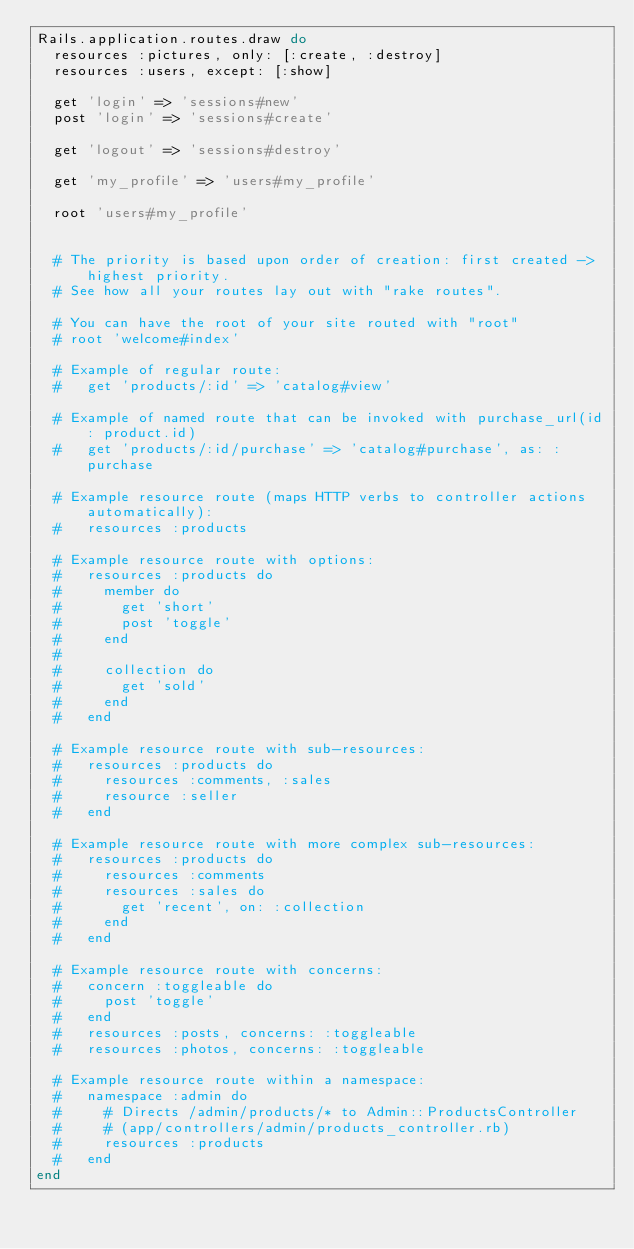<code> <loc_0><loc_0><loc_500><loc_500><_Ruby_>Rails.application.routes.draw do
  resources :pictures, only: [:create, :destroy]
  resources :users, except: [:show]

  get 'login' => 'sessions#new'
  post 'login' => 'sessions#create'

  get 'logout' => 'sessions#destroy'

  get 'my_profile' => 'users#my_profile'

  root 'users#my_profile'


  # The priority is based upon order of creation: first created -> highest priority.
  # See how all your routes lay out with "rake routes".

  # You can have the root of your site routed with "root"
  # root 'welcome#index'

  # Example of regular route:
  #   get 'products/:id' => 'catalog#view'

  # Example of named route that can be invoked with purchase_url(id: product.id)
  #   get 'products/:id/purchase' => 'catalog#purchase', as: :purchase

  # Example resource route (maps HTTP verbs to controller actions automatically):
  #   resources :products

  # Example resource route with options:
  #   resources :products do
  #     member do
  #       get 'short'
  #       post 'toggle'
  #     end
  #
  #     collection do
  #       get 'sold'
  #     end
  #   end

  # Example resource route with sub-resources:
  #   resources :products do
  #     resources :comments, :sales
  #     resource :seller
  #   end

  # Example resource route with more complex sub-resources:
  #   resources :products do
  #     resources :comments
  #     resources :sales do
  #       get 'recent', on: :collection
  #     end
  #   end

  # Example resource route with concerns:
  #   concern :toggleable do
  #     post 'toggle'
  #   end
  #   resources :posts, concerns: :toggleable
  #   resources :photos, concerns: :toggleable

  # Example resource route within a namespace:
  #   namespace :admin do
  #     # Directs /admin/products/* to Admin::ProductsController
  #     # (app/controllers/admin/products_controller.rb)
  #     resources :products
  #   end
end
</code> 